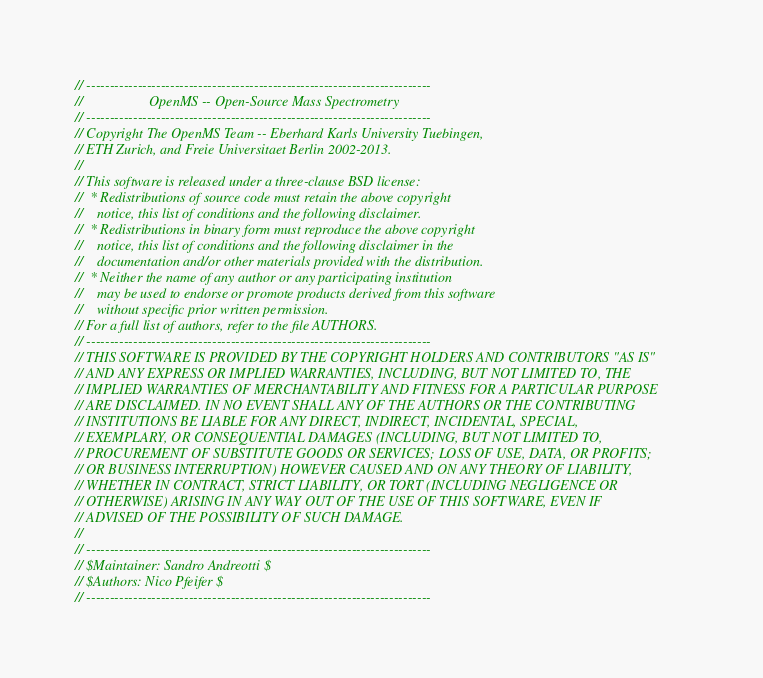Convert code to text. <code><loc_0><loc_0><loc_500><loc_500><_C++_>// --------------------------------------------------------------------------
//                   OpenMS -- Open-Source Mass Spectrometry               
// --------------------------------------------------------------------------
// Copyright The OpenMS Team -- Eberhard Karls University Tuebingen,
// ETH Zurich, and Freie Universitaet Berlin 2002-2013.
// 
// This software is released under a three-clause BSD license:
//  * Redistributions of source code must retain the above copyright
//    notice, this list of conditions and the following disclaimer.
//  * Redistributions in binary form must reproduce the above copyright
//    notice, this list of conditions and the following disclaimer in the
//    documentation and/or other materials provided with the distribution.
//  * Neither the name of any author or any participating institution 
//    may be used to endorse or promote products derived from this software 
//    without specific prior written permission.
// For a full list of authors, refer to the file AUTHORS. 
// --------------------------------------------------------------------------
// THIS SOFTWARE IS PROVIDED BY THE COPYRIGHT HOLDERS AND CONTRIBUTORS "AS IS"
// AND ANY EXPRESS OR IMPLIED WARRANTIES, INCLUDING, BUT NOT LIMITED TO, THE
// IMPLIED WARRANTIES OF MERCHANTABILITY AND FITNESS FOR A PARTICULAR PURPOSE
// ARE DISCLAIMED. IN NO EVENT SHALL ANY OF THE AUTHORS OR THE CONTRIBUTING 
// INSTITUTIONS BE LIABLE FOR ANY DIRECT, INDIRECT, INCIDENTAL, SPECIAL, 
// EXEMPLARY, OR CONSEQUENTIAL DAMAGES (INCLUDING, BUT NOT LIMITED TO, 
// PROCUREMENT OF SUBSTITUTE GOODS OR SERVICES; LOSS OF USE, DATA, OR PROFITS; 
// OR BUSINESS INTERRUPTION) HOWEVER CAUSED AND ON ANY THEORY OF LIABILITY, 
// WHETHER IN CONTRACT, STRICT LIABILITY, OR TORT (INCLUDING NEGLIGENCE OR 
// OTHERWISE) ARISING IN ANY WAY OUT OF THE USE OF THIS SOFTWARE, EVEN IF 
// ADVISED OF THE POSSIBILITY OF SUCH DAMAGE.
// 
// --------------------------------------------------------------------------
// $Maintainer: Sandro Andreotti $
// $Authors: Nico Pfeifer $
// --------------------------------------------------------------------------
</code> 